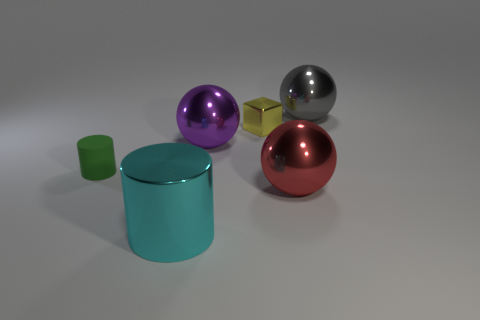What shape is the tiny object to the right of the metal cylinder that is in front of the small thing that is behind the large purple metal ball?
Ensure brevity in your answer.  Cube. Do the cyan shiny cylinder and the yellow shiny cube have the same size?
Offer a very short reply. No. How many things are either red things or big gray balls behind the matte thing?
Provide a short and direct response. 2. How many objects are metallic spheres that are in front of the yellow metallic block or cylinders left of the cyan cylinder?
Keep it short and to the point. 3. Are there any small cylinders behind the green rubber cylinder?
Provide a short and direct response. No. What is the color of the shiny sphere that is in front of the tiny object on the left side of the cylinder that is in front of the red thing?
Offer a terse response. Red. Does the large purple metallic thing have the same shape as the yellow shiny thing?
Keep it short and to the point. No. The cylinder that is made of the same material as the large purple ball is what color?
Give a very brief answer. Cyan. What number of objects are big shiny balls in front of the small metal block or cyan metal things?
Give a very brief answer. 3. What is the size of the gray sphere that is behind the tiny green matte cylinder?
Offer a very short reply. Large. 